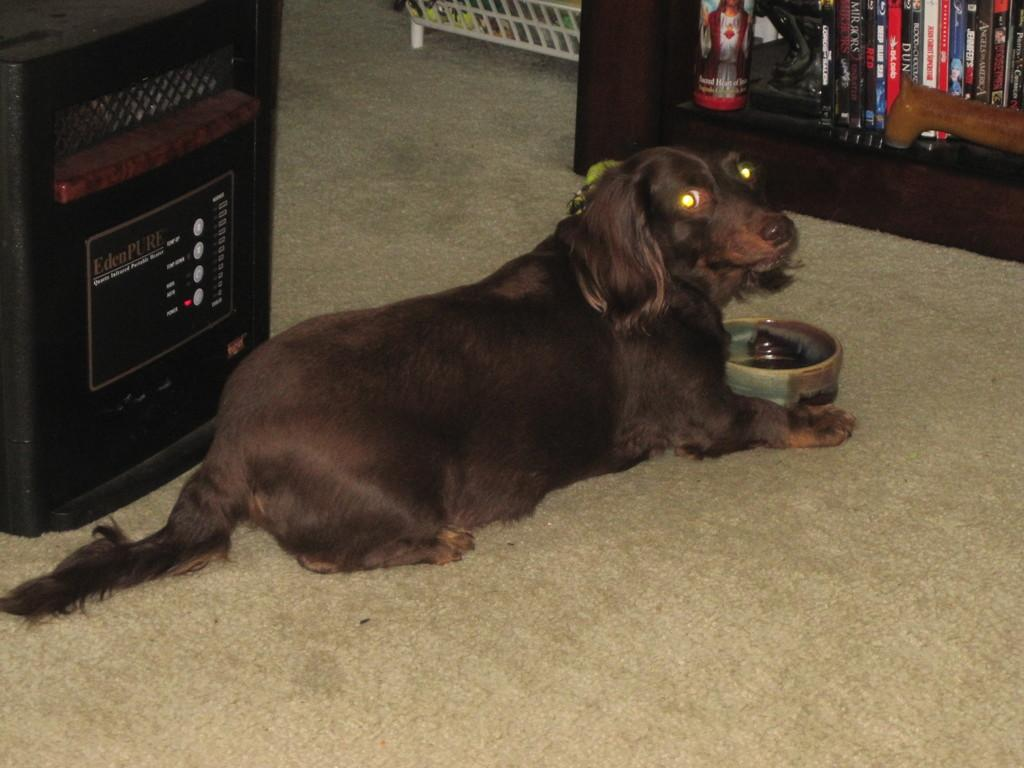What is on the floor in the image? There is a dog on the floor in the image. What is in front of the dog? There is a bowl in front of the dog. What can be seen on the shelves in the image? There are books on shelves in the image. What device is present in the image for producing sound? There is a speaker in the image. What object can be used for holding or serving items in the image? There is a tray in the image. What type of sand can be seen in the image? There is no sand present in the image. How does the pig interact with the books on the shelves in the image? There is no pig present in the image, so it cannot interact with the books on the shelves. 